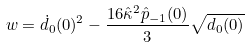Convert formula to latex. <formula><loc_0><loc_0><loc_500><loc_500>w = \dot { d } _ { 0 } ( 0 ) ^ { 2 } - \frac { 1 6 \hat { \kappa } ^ { 2 } \hat { p } _ { - 1 } ( 0 ) } { 3 } \sqrt { d _ { 0 } ( 0 ) }</formula> 